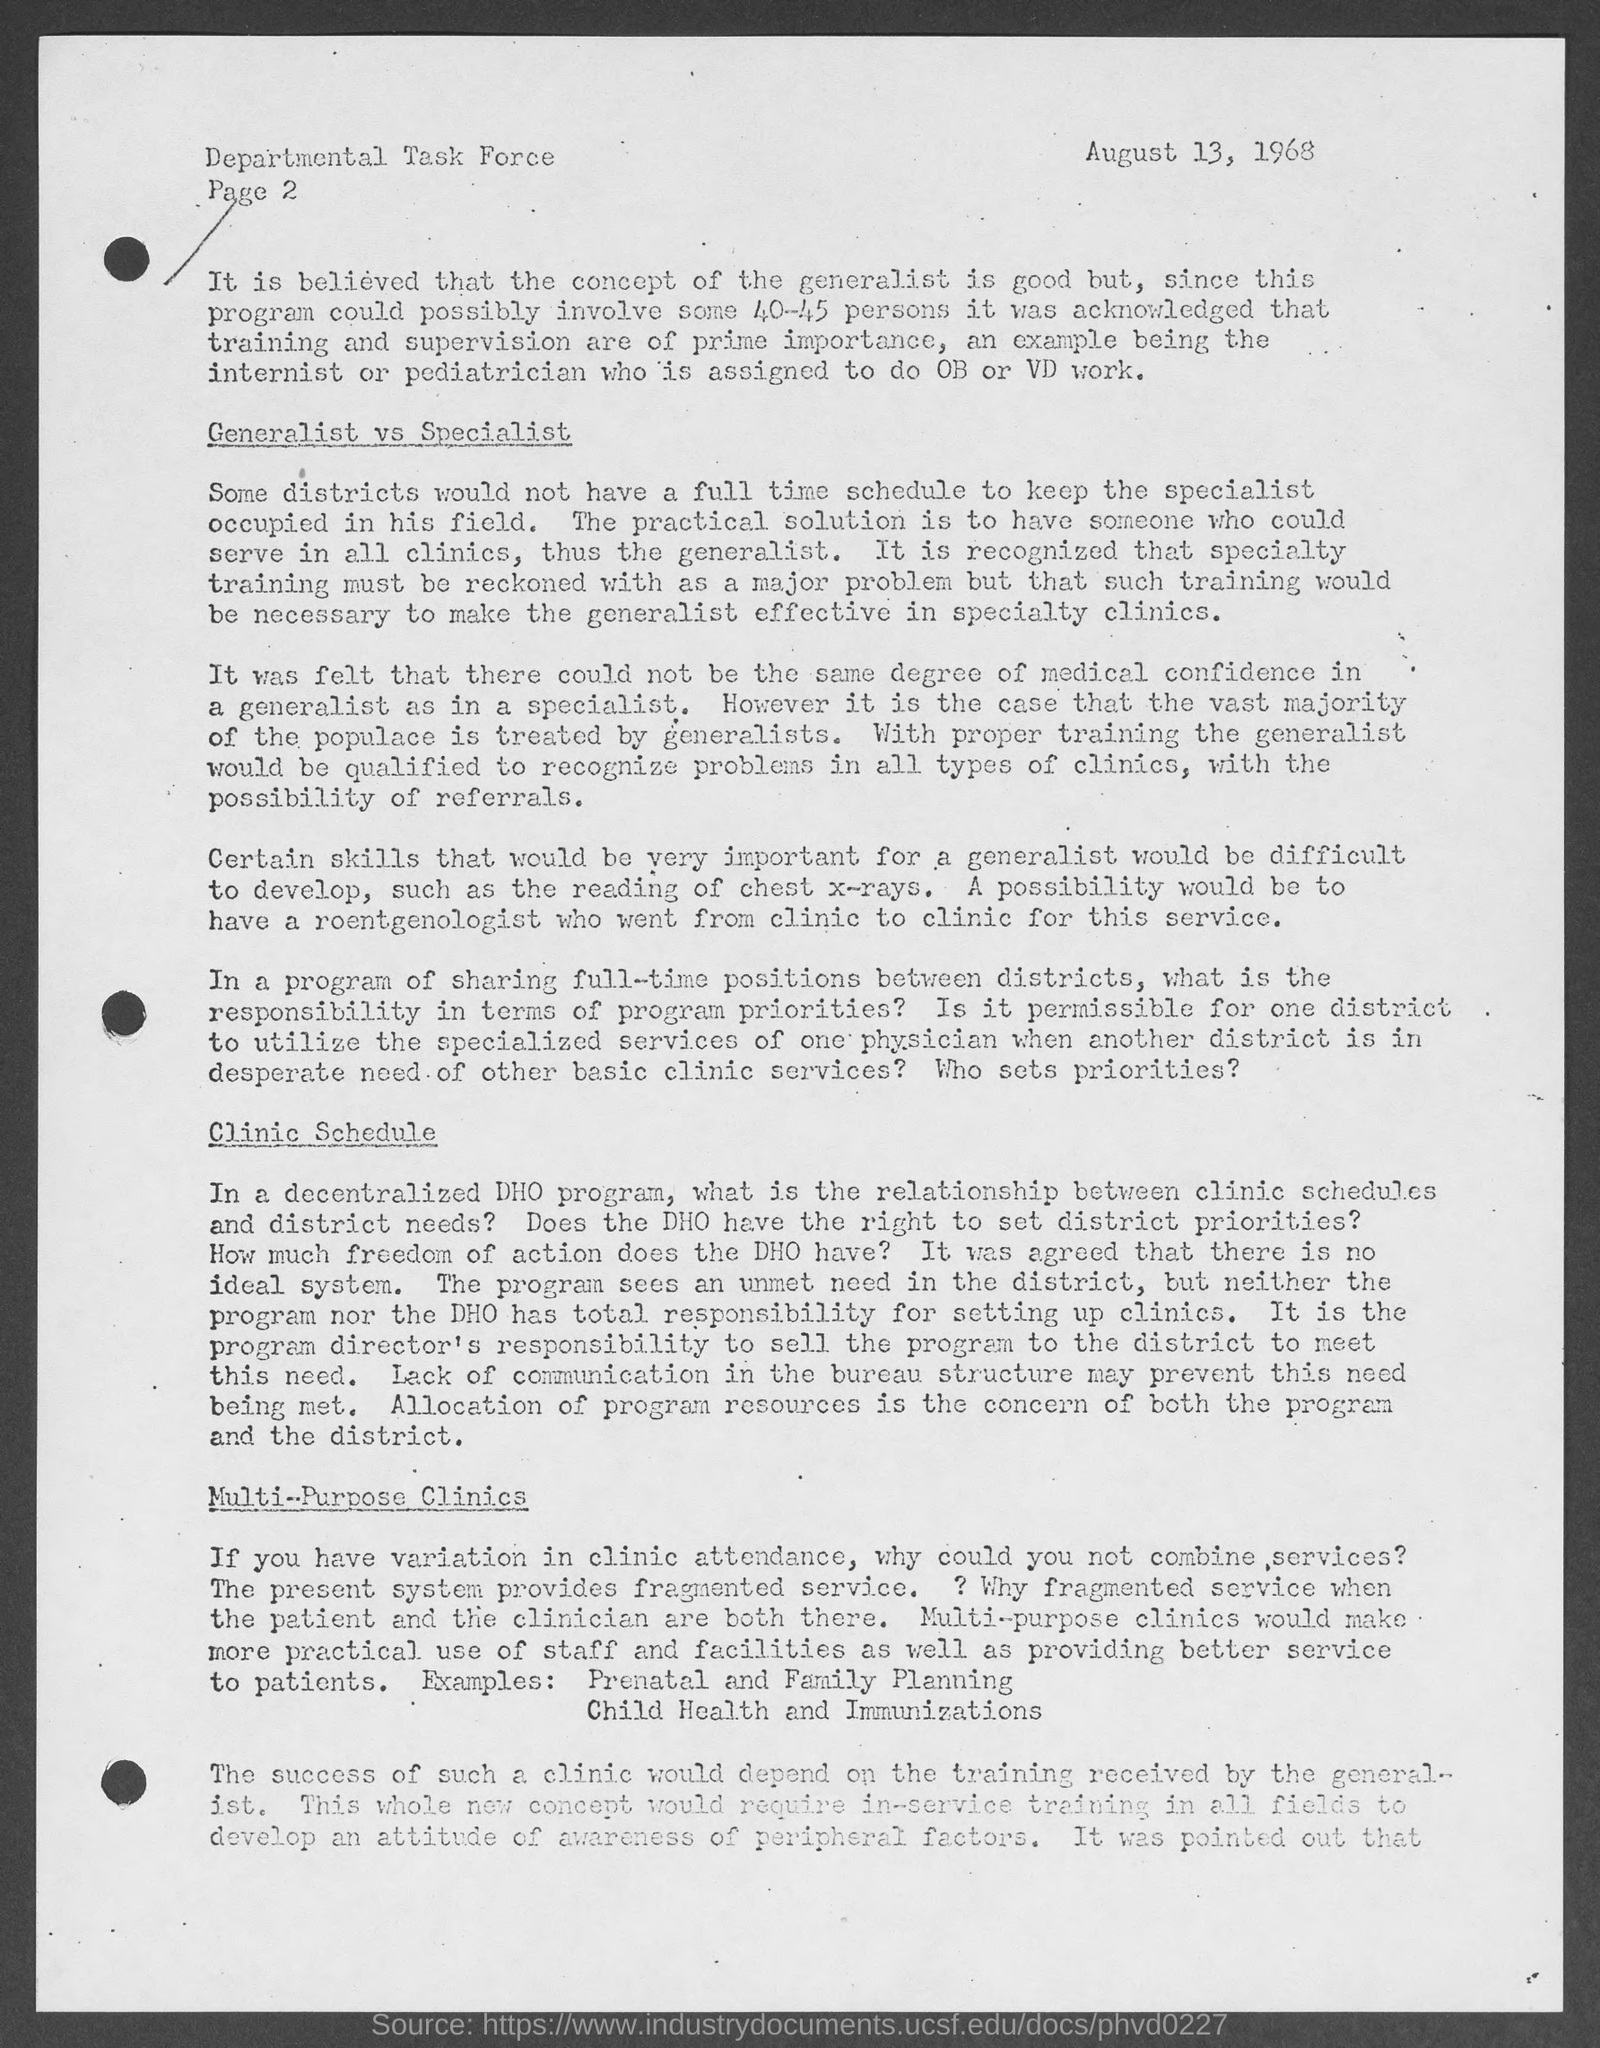What is the page no mentioned in this document?
Your answer should be very brief. Page 2. Which organization is mentioned in the header of the document?
Ensure brevity in your answer.  Departmental task force. 